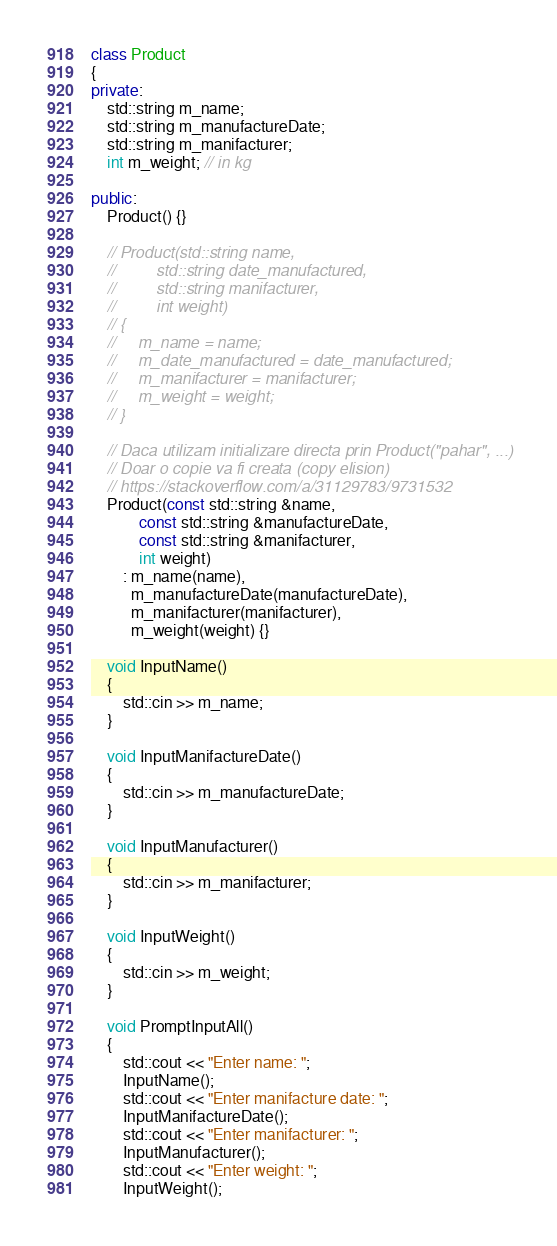Convert code to text. <code><loc_0><loc_0><loc_500><loc_500><_C++_>class Product
{
private:
    std::string m_name;
    std::string m_manufactureDate;
    std::string m_manifacturer;
    int m_weight; // in kg

public:
    Product() {}

    // Product(std::string name,
    //         std::string date_manufactured,
    //         std::string manifacturer,
    //         int weight)
    // {
    //     m_name = name;
    //     m_date_manufactured = date_manufactured;
    //     m_manifacturer = manifacturer;
    //     m_weight = weight;
    // }

    // Daca utilizam initializare directa prin Product("pahar", ...)
    // Doar o copie va fi creata (copy elision)
    // https://stackoverflow.com/a/31129783/9731532
    Product(const std::string &name,
            const std::string &manufactureDate,
            const std::string &manifacturer,
            int weight)
        : m_name(name),
          m_manufactureDate(manufactureDate),
          m_manifacturer(manifacturer),
          m_weight(weight) {}

    void InputName()
    {
        std::cin >> m_name;
    }

    void InputManifactureDate()
    {
        std::cin >> m_manufactureDate;
    }

    void InputManufacturer()
    {
        std::cin >> m_manifacturer;
    }

    void InputWeight()
    {
        std::cin >> m_weight;
    }

    void PromptInputAll()
    {
        std::cout << "Enter name: ";
        InputName();
        std::cout << "Enter manifacture date: ";
        InputManifactureDate();
        std::cout << "Enter manifacturer: ";
        InputManufacturer();
        std::cout << "Enter weight: ";
        InputWeight();</code> 